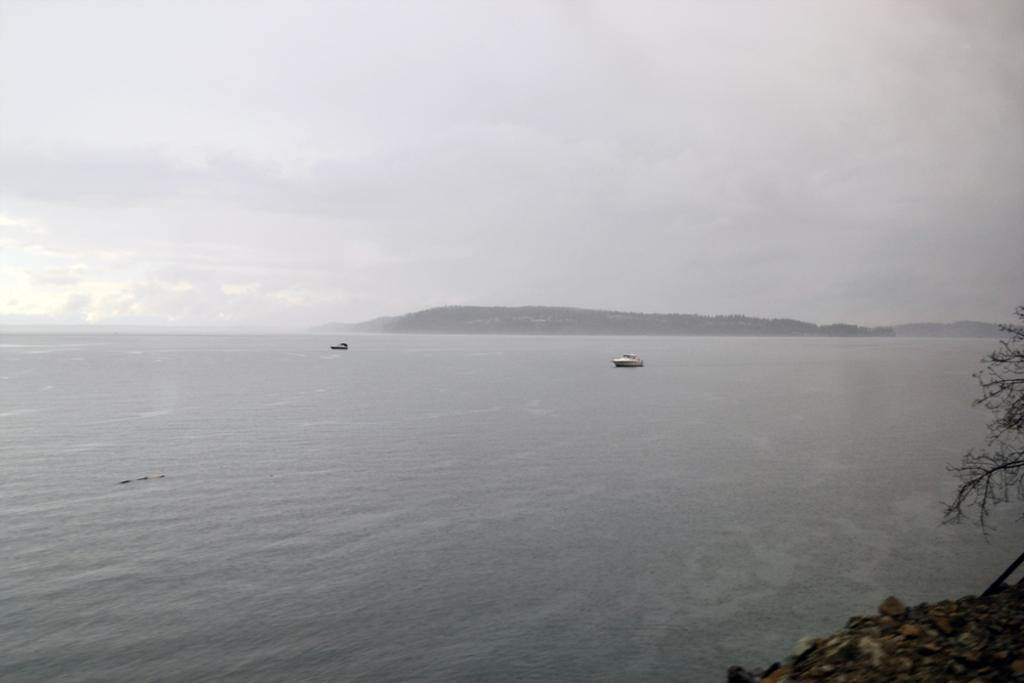What can be seen in the center of the image? There are two boats in the water in the center of the image. What is located on the right side of the image? There is a tree on the right side of the image. What can be seen in the background of the image? There are mountains and the sky visible in the background. What type of bell can be heard ringing in the image? There is no bell present in the image, so it is not possible to hear it ringing. How many feet are visible in the image? There are no feet visible in the image. 